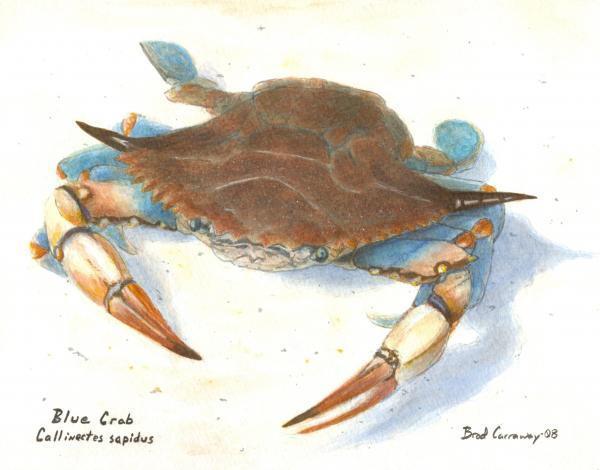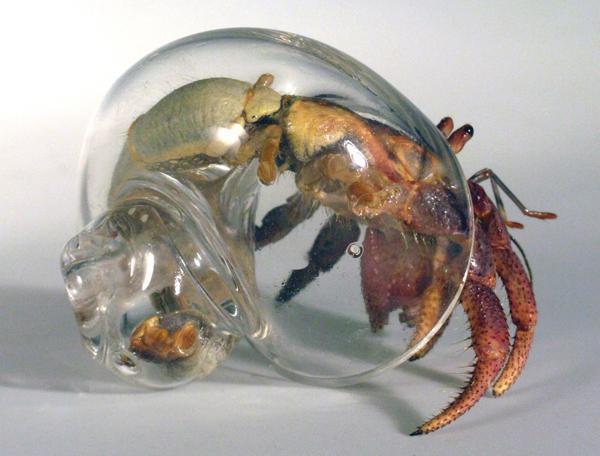The first image is the image on the left, the second image is the image on the right. Examine the images to the left and right. Is the description "The left image contains one forward-facing crab with its front claws somewhat extended and its top shell visible." accurate? Answer yes or no. Yes. 